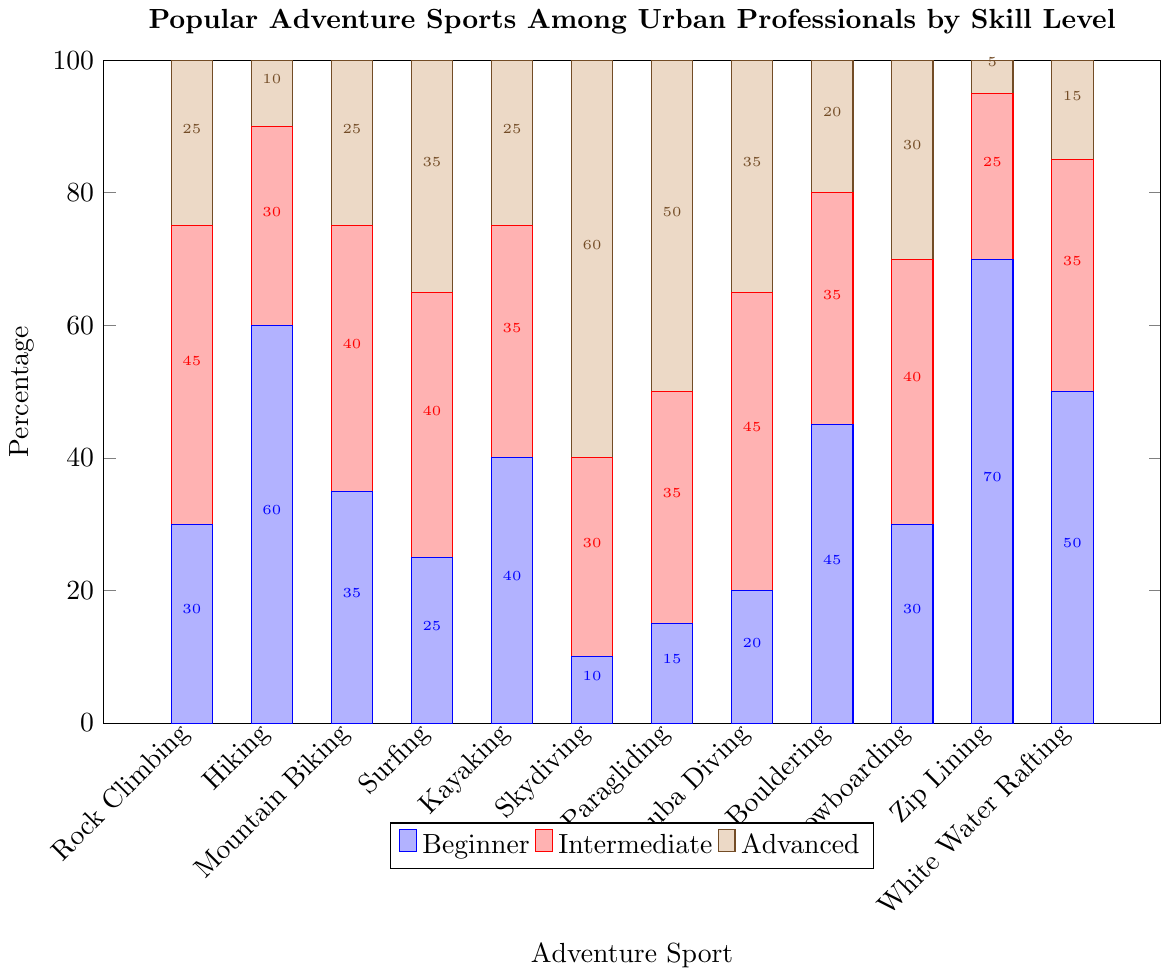What adventure sport has the highest percentage of beginners? Look at the first set of bars (Beginner) and find the sport with the tallest bar.
Answer: Zip Lining Which adventure sports require more advanced skill levels than intermediate? Compare the third set of bars (Advanced) to the second set (Intermediate) and identify the sports where the Advanced bar is taller than the Intermediate bar.
Answer: Surfing, Skydiving, Paragliding What is the total percentage of people who participate in hiking? Add the height of the Hiking bars across Beginner (60%), Intermediate (30%), and Advanced (10%) categories.
Answer: 100% Which adventure sport has an equal number of beginners and intermediates? Check for sports where the Beginner and Intermediate bars have the same height by visual inspection.
Answer: Bouldering What is the average percentage of advanced participants in Mountain Biking and Surfing combined? Add the percentage of advanced participants in both sports and divide by 2. Mountain Biking (25%) + Surfing (35%) = 60%, then divide by 2.
Answer: 30% 